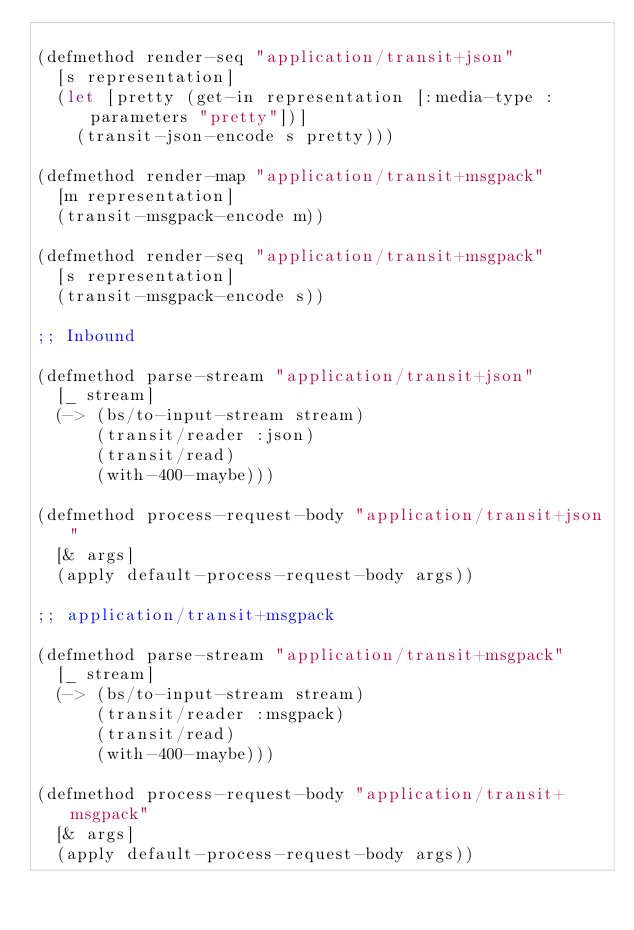Convert code to text. <code><loc_0><loc_0><loc_500><loc_500><_Clojure_>
(defmethod render-seq "application/transit+json"
  [s representation]
  (let [pretty (get-in representation [:media-type :parameters "pretty"])]
    (transit-json-encode s pretty)))

(defmethod render-map "application/transit+msgpack"
  [m representation]
  (transit-msgpack-encode m))

(defmethod render-seq "application/transit+msgpack"
  [s representation]
  (transit-msgpack-encode s))

;; Inbound

(defmethod parse-stream "application/transit+json"
  [_ stream]
  (-> (bs/to-input-stream stream)
      (transit/reader :json)
      (transit/read)
      (with-400-maybe)))

(defmethod process-request-body "application/transit+json"
  [& args]
  (apply default-process-request-body args))

;; application/transit+msgpack

(defmethod parse-stream "application/transit+msgpack"
  [_ stream]
  (-> (bs/to-input-stream stream)
      (transit/reader :msgpack)
      (transit/read)
      (with-400-maybe)))

(defmethod process-request-body "application/transit+msgpack"
  [& args]
  (apply default-process-request-body args))
</code> 